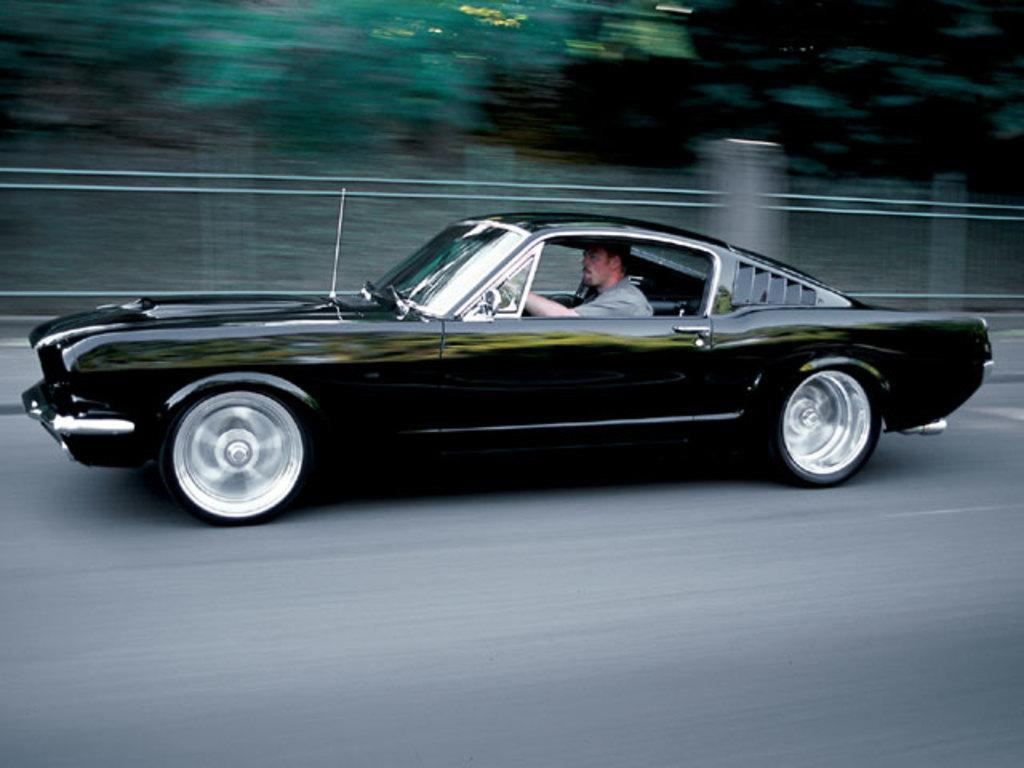In one or two sentences, can you explain what this image depicts? It is a road a man is riding a car, the car is of black color ,the images taken while the car is in motion, in the background there are some trees. 